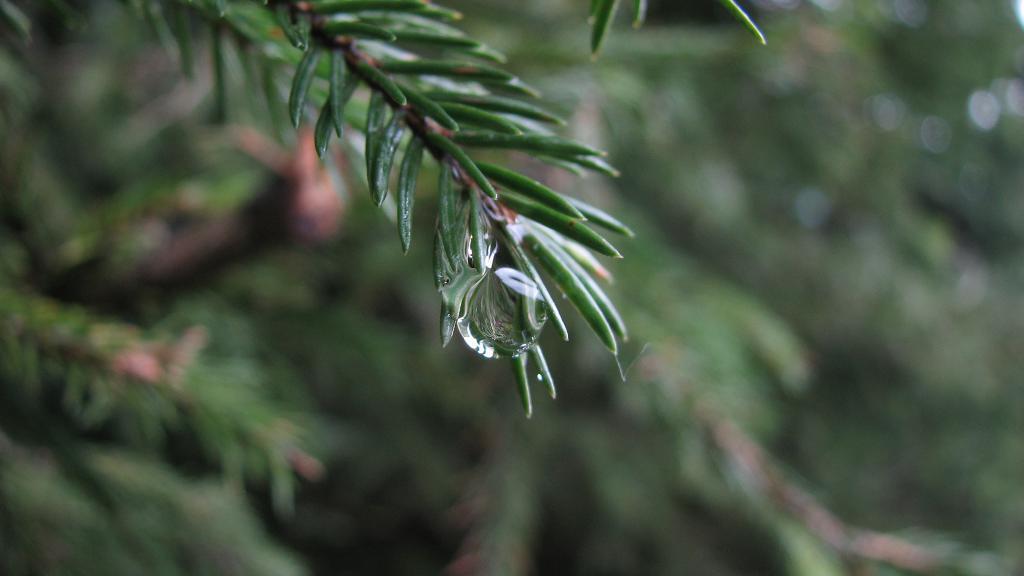In one or two sentences, can you explain what this image depicts? In this image I can see number of green colour leaves and in the center of the image I can see a water drop. I can also see this image is blurry in the background. 